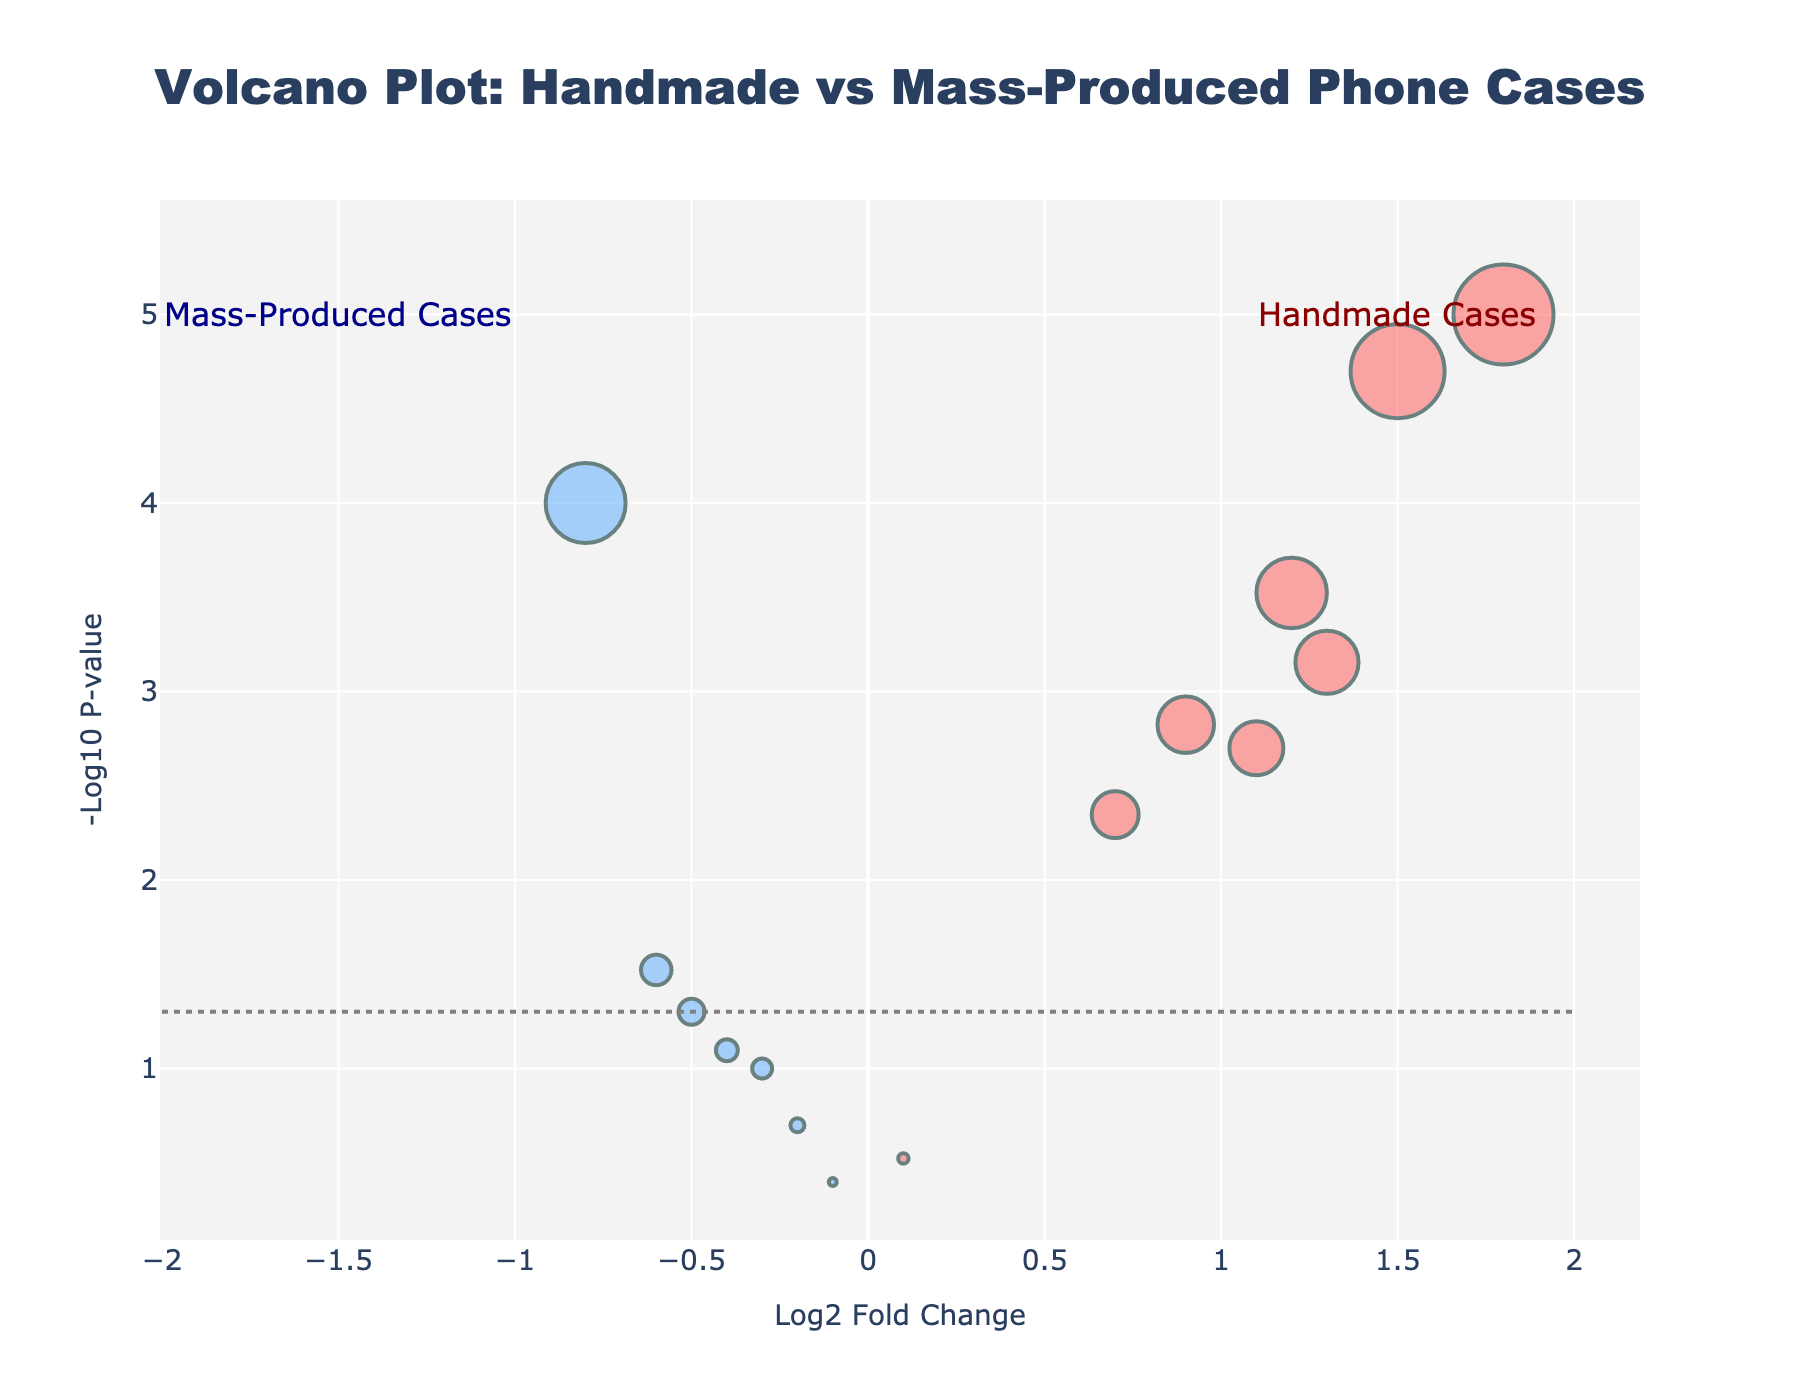How many handmade phone cases have statistically significant differences in their sentiment scores? We look for the phone cases associated with a log2 fold change and a p-value below the threshold line at -log10(0.05). Handmade phone cases are highlighted in red (upper-right quadrant). Count these points.
Answer: 8 Which handmade phone case has the highest log2 fold change? Locate the red points on the graph and identify the one with the highest x-axis value.
Answer: Handmade Resin Ocean Waves Case How many phone cases fall below the p-value threshold of 0.05? Count all the dots below the y-axis value representing -log10(0.05) for both handmade and mass-produced phone cases.
Answer: 10 Among the mass-produced cases, which one shows the most negative sentiment score? Identify the blue points in the negative region of the log2 fold change (left-side of the plot) and find which has the lowest x-axis value.
Answer: UAG Monarch Series What is the sentiment score change for the "Mandala Art Personalized Case" compared to mass-produced cases? Find the “Mandala Art Personalized Case” point on the plot. Compare its log2 fold change (1.5) with that of mass-produced cases, focusing on their position (usually lower or negative).
Answer: Higher Which product shows the largest sentiment p-value? Identify the dot closest to the x-axis, which indicates the highest p-value (-log10(p-value) is smallest).
Answer: Mous Limitless 3.0 Do more handmade or mass-produced phone cases have statistically significant differences in their sentiment scores? Count the significant points for both red (handmade) and blue (mass-produced) points. Compare the counts.
Answer: Handmade Which phone case has the most statistically significant positive change in sentiment score? Find the point furthest along the y-axis in the positive region (highest -log10(p-value)) and on the right side of the x-axis.
Answer: Handmade Resin Ocean Waves Case What can we infer about the sentiment scores of mass-produced cases compared to handmade ones? Compare the distribution of red and blue points. Most red points (handmade) are concentrated on the positive side with significant p-values, while blue points (mass-produced) are largely in the middle or negative side, many with non-significant p-values.
Answer: Handmade cases generally have higher sentiment scores 